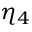<formula> <loc_0><loc_0><loc_500><loc_500>\eta _ { 4 }</formula> 